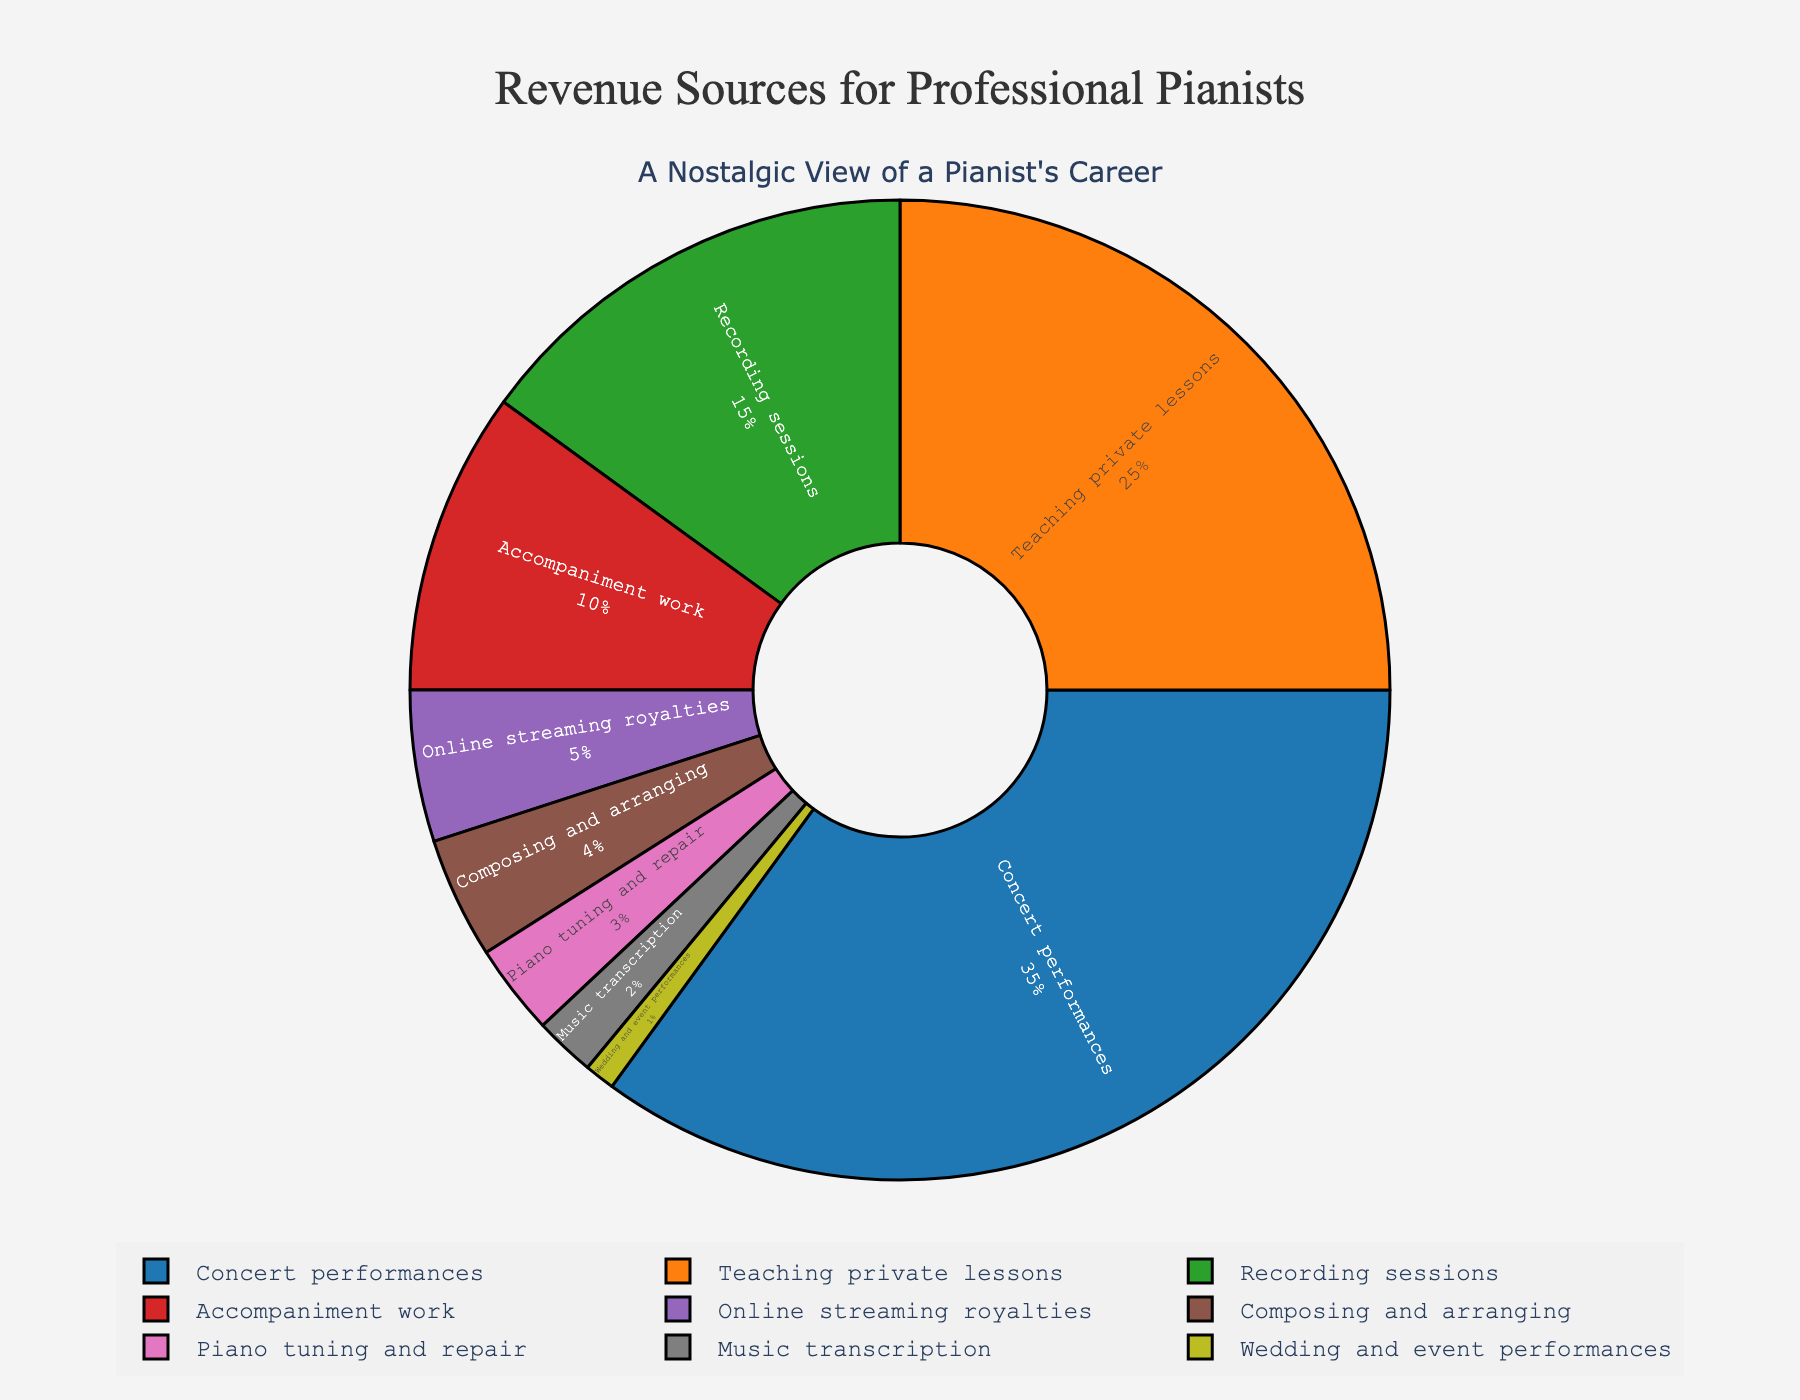What percentage of revenue comes from concert performances and teaching private lessons combined? To find the total percentage of revenue coming from concert performances and teaching private lessons, we add the individual percentages. Concert performances contribute 35%, and teaching private lessons contribute 25%. Adding these gives 35% + 25% = 60%.
Answer: 60% Which category contributes less to revenue: recording sessions or accompaniment work? We compare the percentages of the two categories. Recording sessions contribute 15%, while accompaniment work contributes 10%. Since 10% is less than 15%, accompaniment work contributes less to revenue.
Answer: Accompaniment work What is the color used to represent concert performances in the pie chart? By examining the visual attributes of the chart, concert performances are represented by the first segment, which is color-coded in a light blue shade.
Answer: Light blue Is the percentage contribution from online streaming royalties greater or less than composing and arranging? The percentage for online streaming royalties is 5%, and the percentage for composing and arranging is 4%. Since 5% is greater than 4%, online streaming royalties contribute more.
Answer: Greater How much revenue comes from activities making up less than 5% individually? We add the percentages of categories that individually contribute less than 5%: composing and arranging (4%), piano tuning and repair (3%), music transcription (2%), and wedding and event performances (1%). The combined percentage is 4% + 3% + 2% + 1% = 10%.
Answer: 10% Which activity has the smallest contribution to revenue and what is its percentage? The smallest contribution to revenue as shown in the pie chart is from wedding and event performances, which is 1%.
Answer: Wedding and event performances, 1% What percentage difference is there between accompaniment work and teaching private lessons? The percentage for teaching private lessons is 25%, and the percentage for accompaniment work is 10%. To find the difference, we subtract the smaller percentage from the larger one: 25% - 10% = 15%.
Answer: 15% What visual element in the chart signifies that it represents a partial view of the whole? The pie chart has a hole in the center, indicating it is a donut chart which is often used to signify partial data or to create a specific visual focus.
Answer: Hole in the center 